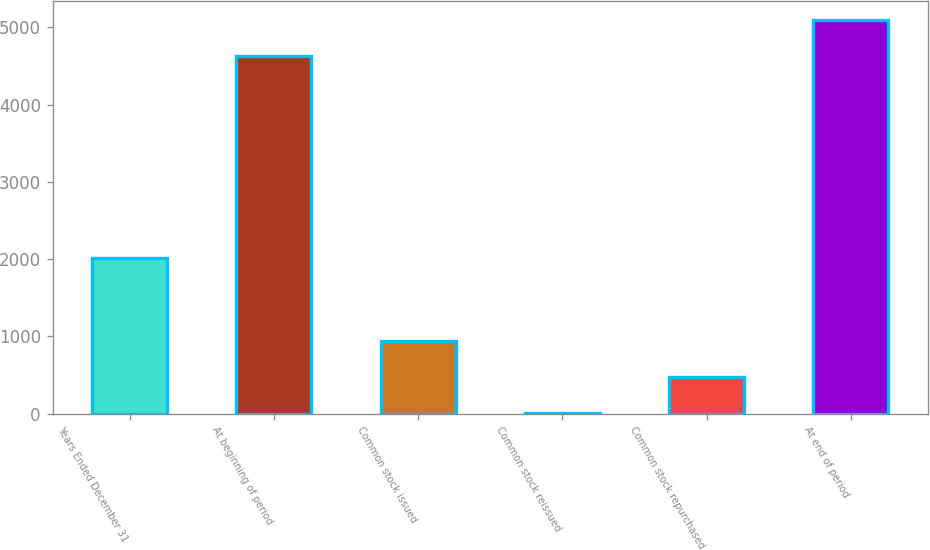Convert chart. <chart><loc_0><loc_0><loc_500><loc_500><bar_chart><fcel>Years Ended December 31<fcel>At beginning of period<fcel>Common stock issued<fcel>Common stock reissued<fcel>Common stock repurchased<fcel>At end of period<nl><fcel>2012<fcel>4627<fcel>938.6<fcel>6<fcel>472.3<fcel>5093.3<nl></chart> 